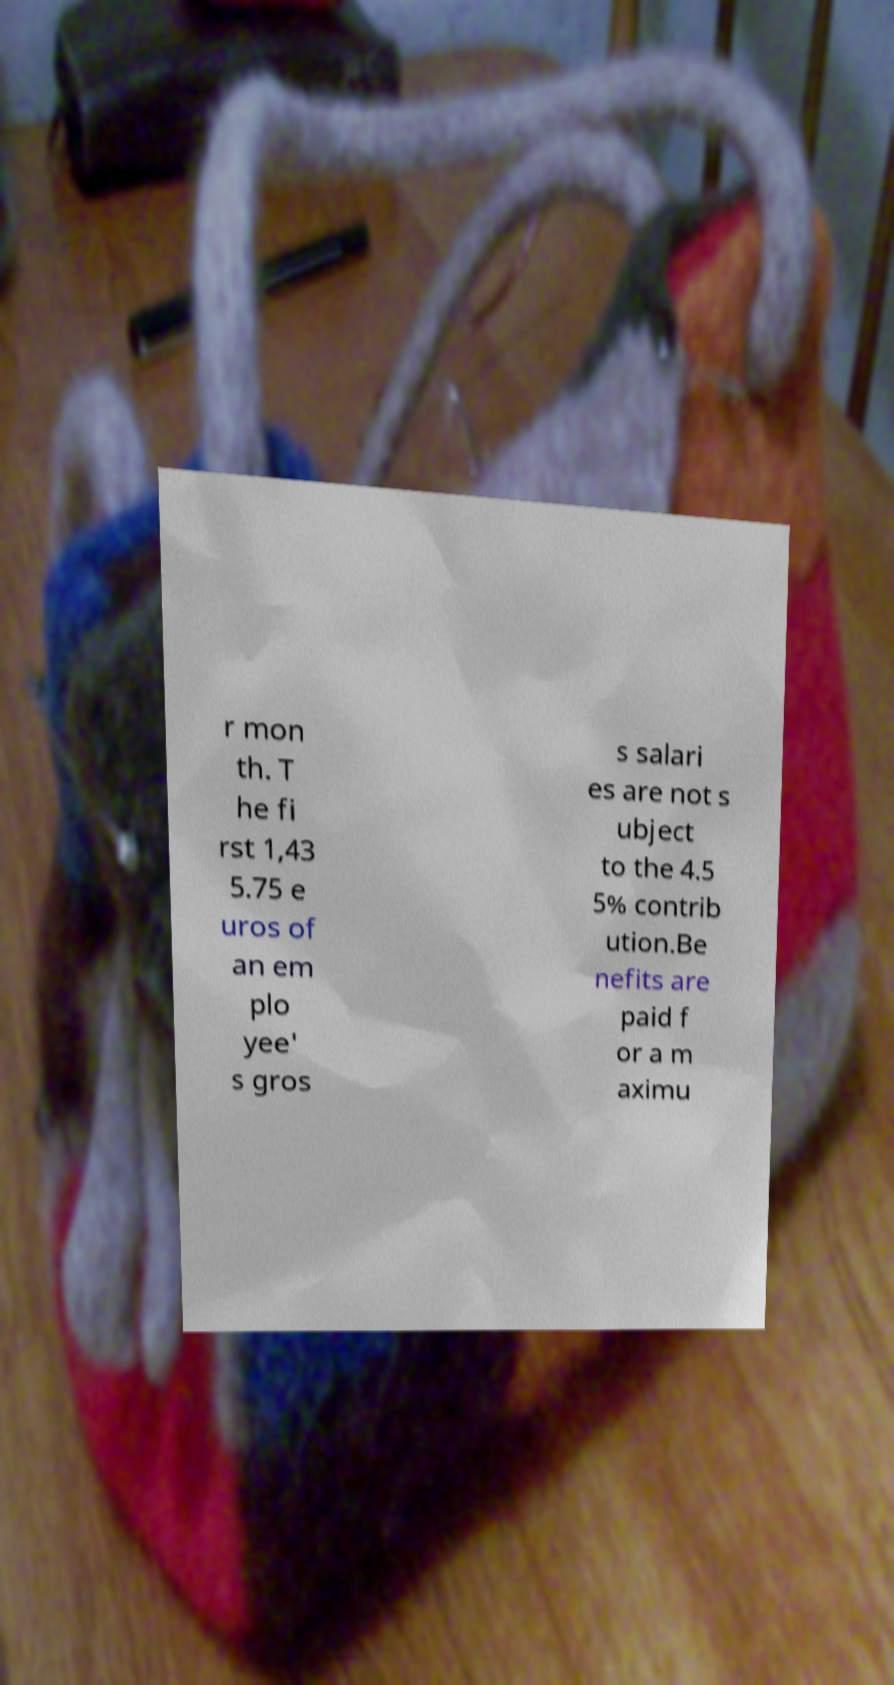Please read and relay the text visible in this image. What does it say? r mon th. T he fi rst 1,43 5.75 e uros of an em plo yee' s gros s salari es are not s ubject to the 4.5 5% contrib ution.Be nefits are paid f or a m aximu 